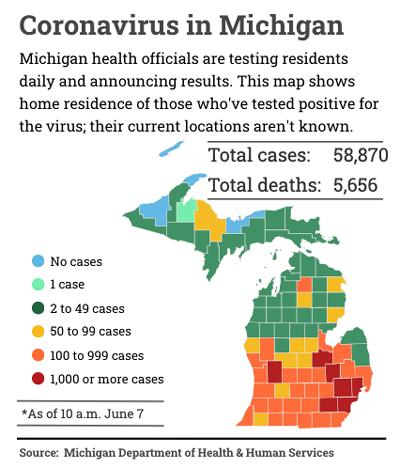Draw attention to some important aspects in this diagram. In 50 to 99 cases, yellow, red, and blue have been used to represent colors. The red color on the map indicates cases with more than 1,000 reported cases. Out of the total number of cases, a significant percentage of individuals are currently alive. Specifically, a total of 53,214 individuals are currently thriving. Seventh-grader: "How many schools have 1000 or more students?"

Teacher: "Seventh-grader, you are asking about the number of schools that have 1000 or more students. 